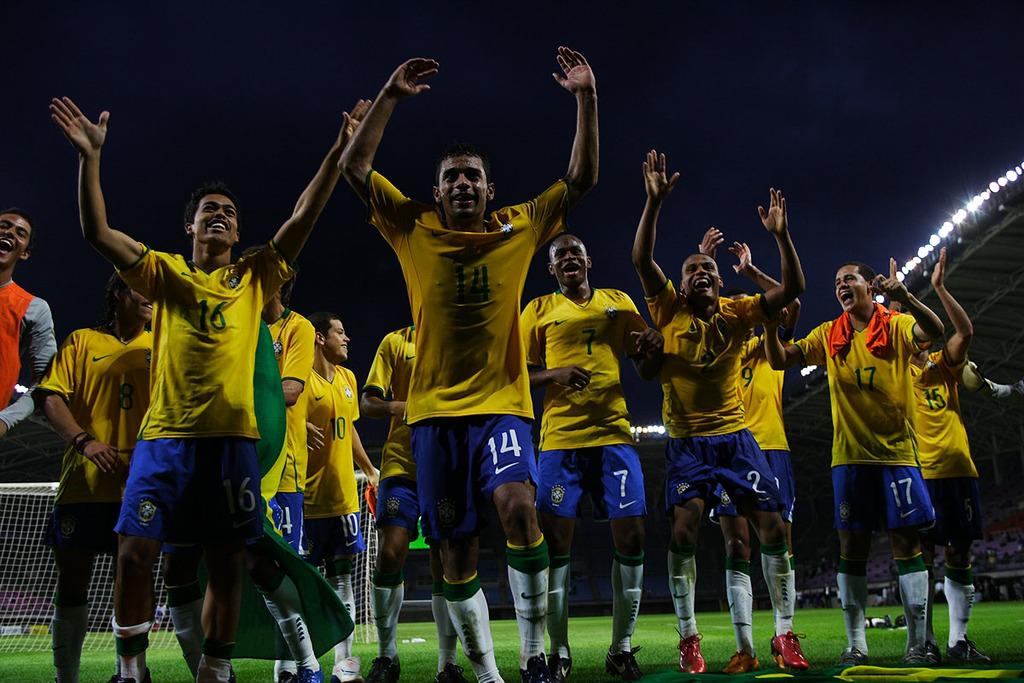What is the main subject of the image? The main subject of the image is a group of people. What are the people in the image doing? The people are standing. What colors are the people wearing in the image? The people are wearing yellow and blue color dress. What can be seen in the background of the image? There is a net and lights in the background of the image. Can you tell me how many pears are on the table in the image? There is no table or pear present in the image. What type of tin is visible in the image? There is no tin present in the image. 